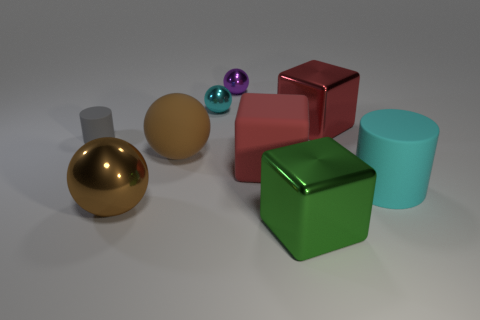There is a object that is the same color as the rubber cube; what shape is it?
Your response must be concise. Cube. Is the material of the purple thing the same as the cyan cylinder?
Give a very brief answer. No. Is the number of red matte blocks that are in front of the big cyan object greater than the number of large red things?
Your answer should be compact. No. How many things are either metal cubes or things that are to the left of the red metallic cube?
Your answer should be very brief. 8. Is the number of brown objects that are in front of the large cyan rubber thing greater than the number of big brown objects that are behind the gray thing?
Provide a short and direct response. Yes. There is a small object in front of the cyan thing behind the big metallic object that is behind the large cyan matte cylinder; what is its material?
Offer a terse response. Rubber. The tiny purple thing that is made of the same material as the cyan sphere is what shape?
Your response must be concise. Sphere. There is a metallic thing in front of the big brown metallic thing; is there a large shiny thing that is in front of it?
Ensure brevity in your answer.  No. The purple metal object has what size?
Your answer should be compact. Small. What number of objects are gray cylinders or small red metallic cylinders?
Offer a very short reply. 1. 